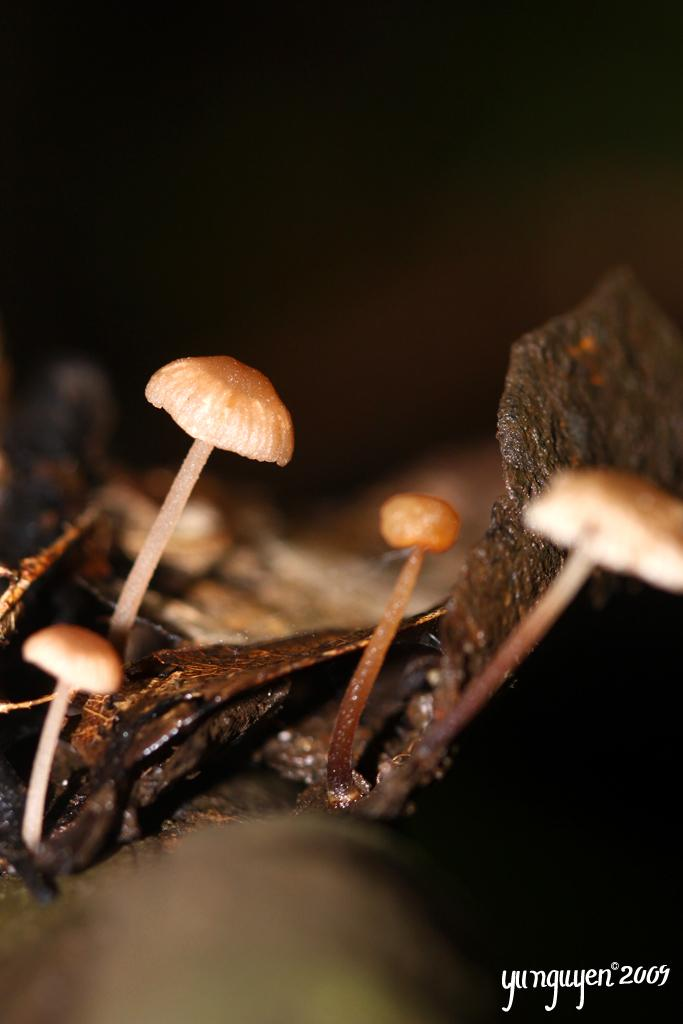What type of fungi can be seen in the image? There are mushrooms in the image. Can you describe the background of the image? The background of the image is blurred. What is located at the bottom of the image? There is text at the bottom of the image. How many degrees can be seen in the image? There are no degrees present in the image; it features mushrooms and text. What type of bean is visible in the image? There is no bean present in the image. 